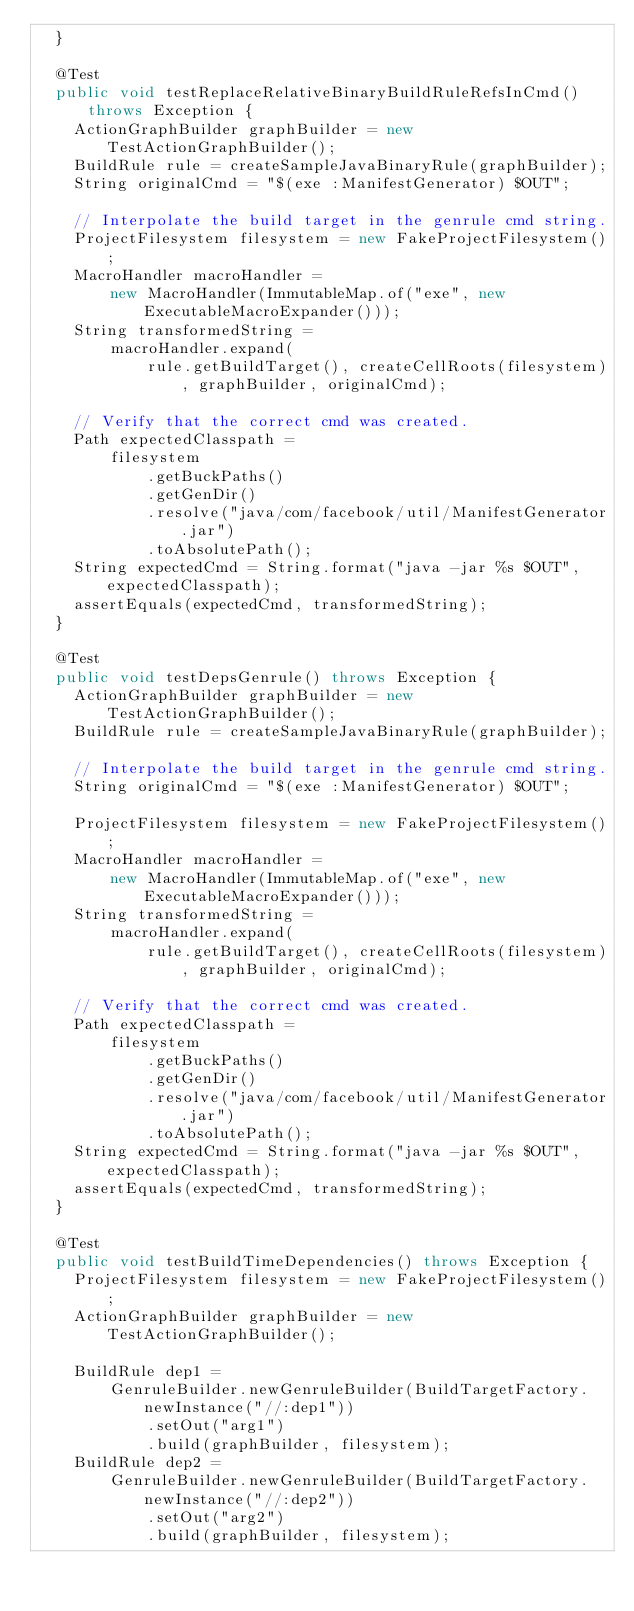Convert code to text. <code><loc_0><loc_0><loc_500><loc_500><_Java_>  }

  @Test
  public void testReplaceRelativeBinaryBuildRuleRefsInCmd() throws Exception {
    ActionGraphBuilder graphBuilder = new TestActionGraphBuilder();
    BuildRule rule = createSampleJavaBinaryRule(graphBuilder);
    String originalCmd = "$(exe :ManifestGenerator) $OUT";

    // Interpolate the build target in the genrule cmd string.
    ProjectFilesystem filesystem = new FakeProjectFilesystem();
    MacroHandler macroHandler =
        new MacroHandler(ImmutableMap.of("exe", new ExecutableMacroExpander()));
    String transformedString =
        macroHandler.expand(
            rule.getBuildTarget(), createCellRoots(filesystem), graphBuilder, originalCmd);

    // Verify that the correct cmd was created.
    Path expectedClasspath =
        filesystem
            .getBuckPaths()
            .getGenDir()
            .resolve("java/com/facebook/util/ManifestGenerator.jar")
            .toAbsolutePath();
    String expectedCmd = String.format("java -jar %s $OUT", expectedClasspath);
    assertEquals(expectedCmd, transformedString);
  }

  @Test
  public void testDepsGenrule() throws Exception {
    ActionGraphBuilder graphBuilder = new TestActionGraphBuilder();
    BuildRule rule = createSampleJavaBinaryRule(graphBuilder);

    // Interpolate the build target in the genrule cmd string.
    String originalCmd = "$(exe :ManifestGenerator) $OUT";

    ProjectFilesystem filesystem = new FakeProjectFilesystem();
    MacroHandler macroHandler =
        new MacroHandler(ImmutableMap.of("exe", new ExecutableMacroExpander()));
    String transformedString =
        macroHandler.expand(
            rule.getBuildTarget(), createCellRoots(filesystem), graphBuilder, originalCmd);

    // Verify that the correct cmd was created.
    Path expectedClasspath =
        filesystem
            .getBuckPaths()
            .getGenDir()
            .resolve("java/com/facebook/util/ManifestGenerator.jar")
            .toAbsolutePath();
    String expectedCmd = String.format("java -jar %s $OUT", expectedClasspath);
    assertEquals(expectedCmd, transformedString);
  }

  @Test
  public void testBuildTimeDependencies() throws Exception {
    ProjectFilesystem filesystem = new FakeProjectFilesystem();
    ActionGraphBuilder graphBuilder = new TestActionGraphBuilder();

    BuildRule dep1 =
        GenruleBuilder.newGenruleBuilder(BuildTargetFactory.newInstance("//:dep1"))
            .setOut("arg1")
            .build(graphBuilder, filesystem);
    BuildRule dep2 =
        GenruleBuilder.newGenruleBuilder(BuildTargetFactory.newInstance("//:dep2"))
            .setOut("arg2")
            .build(graphBuilder, filesystem);
</code> 